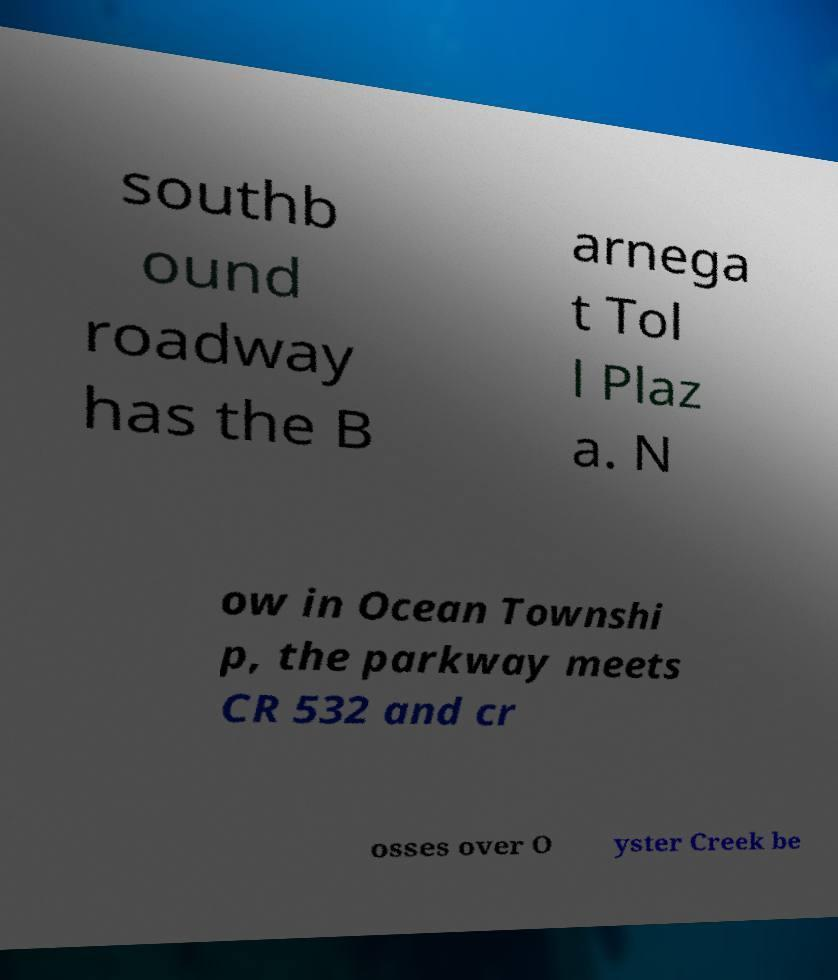For documentation purposes, I need the text within this image transcribed. Could you provide that? southb ound roadway has the B arnega t Tol l Plaz a. N ow in Ocean Townshi p, the parkway meets CR 532 and cr osses over O yster Creek be 